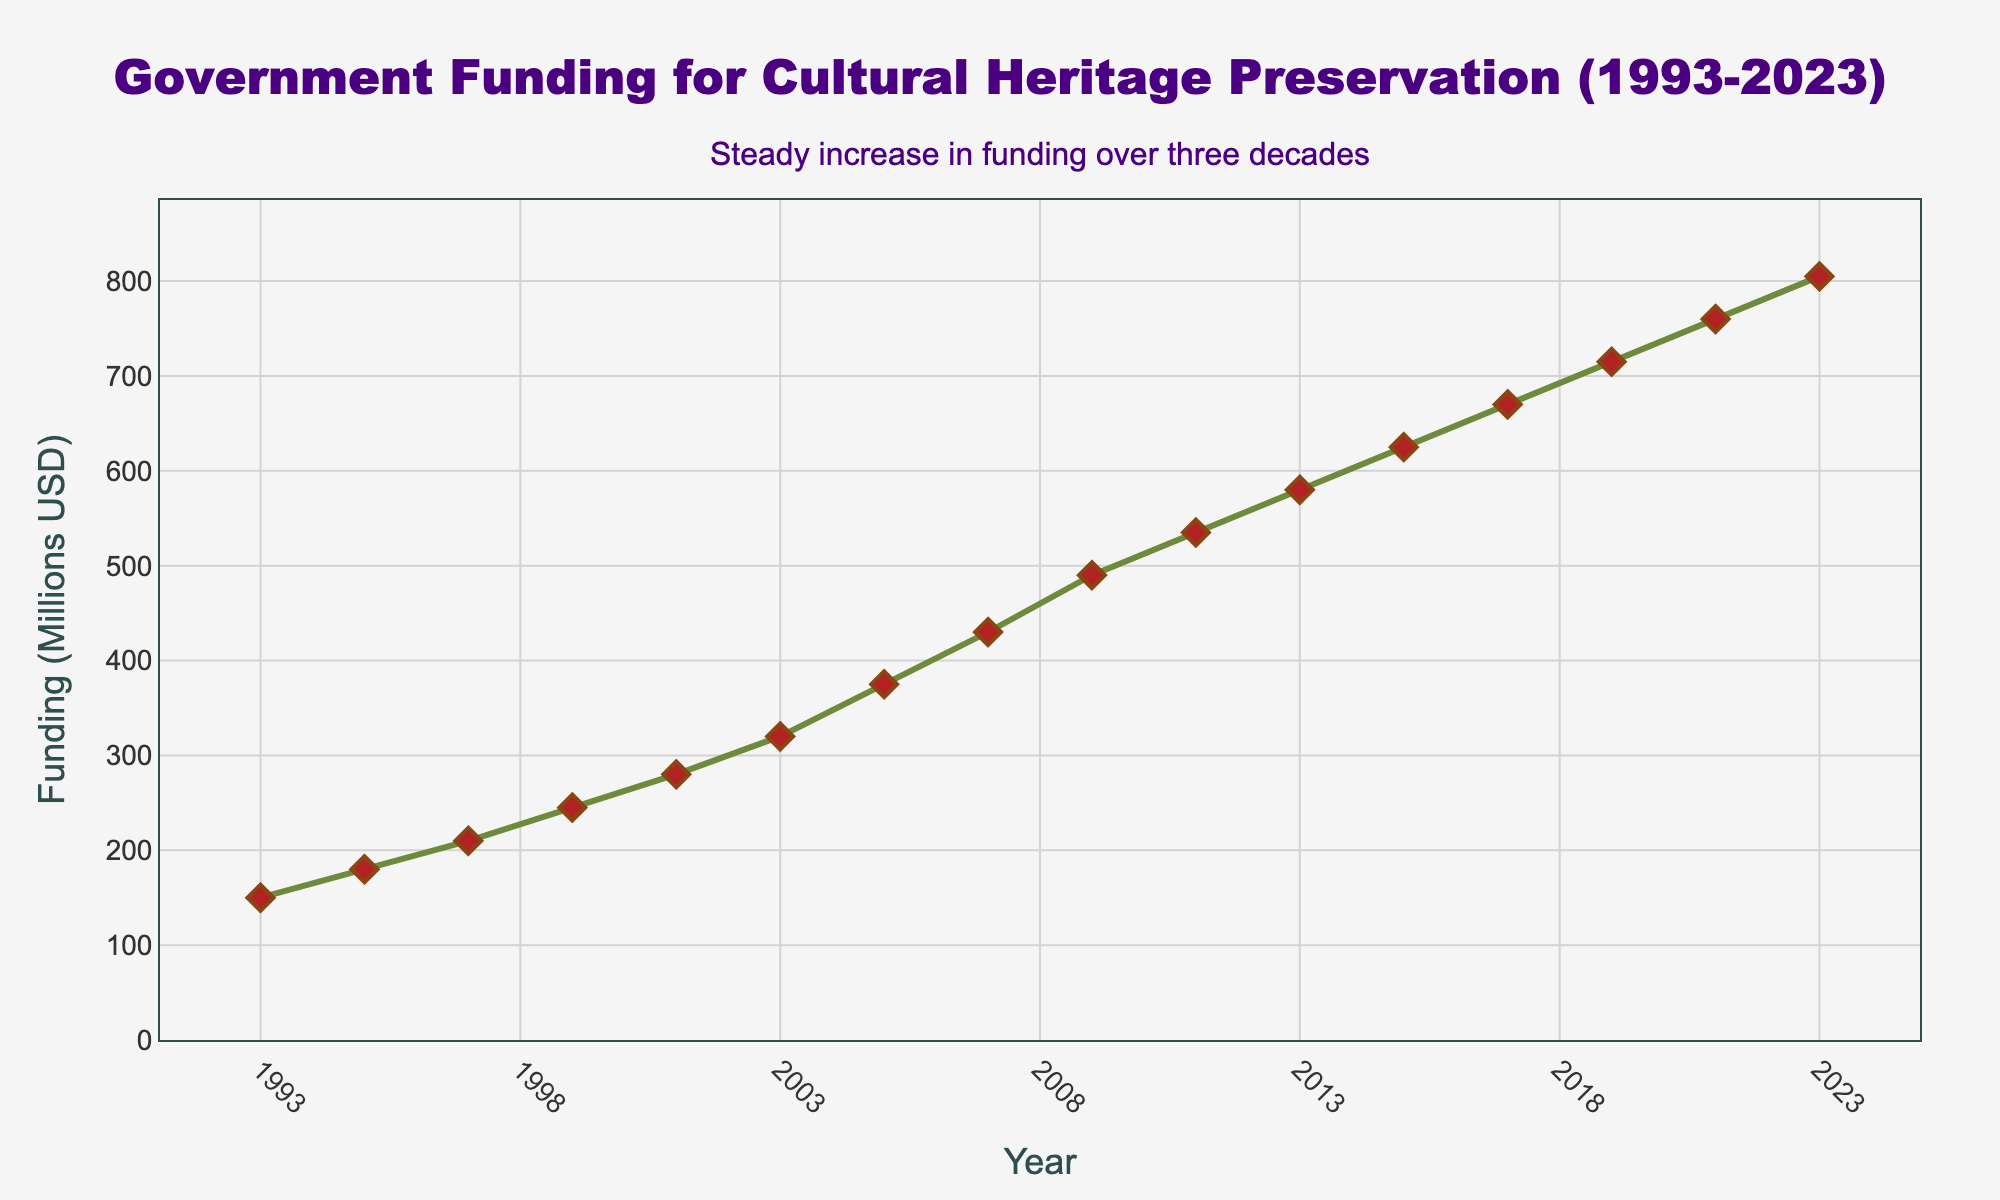What is the total funding allocated for cultural heritage preservation from 1993 to 2023? Sum up the funding values for each year from 1993 to 2023 mentioned in the dataset: 150 + 180 + 210 + 245 + 280 + 320 + 375 + 430 + 490 + 535 + 580 + 625 + 670 + 715 + 760 + 805 = 7870
Answer: 7870 Between which years did the funding experience the largest increase, and what was the amount of this increase? Calculate the differences between consecutive years' funding, and identify the largest difference. The differences are: 180-150=30, 210-180=30, 245-210=35, 280-245=35, 320-280=40, 375-320=55, 430-375=55, 490-430=60, 535-490=45, 580-535=45, 625-580=45, 670-625=45, 715-670=45, 760-715=45, 805-760=45. The largest increase is 60, which occurred between 2007 and 2009.
Answer: 2007 to 2009, 60 million USD What is the average annual funding over the 30-year period? Sum the funding values from 1993 to 2023, then divide by the number of years (7870/16). The calculation is 7870/16 = 491.875
Answer: 491.875 million USD What can you infer about the overall trend in government funding for cultural heritage preservation from 1993 to 2023? Examine the line chart and observe the trend in funding over the years. The trend shows a steady and continuous increase in funding, without any noticeable declines, indicating a positive commitment to cultural heritage preservation.
Answer: Steady increase Which year had the lowest funding allocation, and what was the amount? Look for the lowest point on the line chart, which corresponds to the year with the minimum funding. In the dataset, the lowest funding is 150 million USD in 1993.
Answer: 1993, 150 million USD By how much did the funding increase from 1993 to 2023? Subtract the funding amount in 1993 from the funding amount in 2023: 805 - 150 = 655 million USD
Answer: 655 million USD In which time span did the funding grow more rapidly: 1993-2003 or 2013-2023? Calculate the total funding increases for each period: (320-150) = 170 million for 1993-2003, and (805-580) = 225 million for 2013-2023. Comparing these increases, the growth is more rapid in the period 2013-2023.
Answer: 2013-2023 What is the median funding value during this 30-year period? Sort the funding values and identify the middle value. The sorted values are: 150, 180, 210, 245, 280, 320, 375, 430, 490, 535, 580, 625, 670, 715, 760, 805. With 16 data points, the median is the average of the 8th and 9th values: (430 + 490) / 2 = 460
Answer: 460 million USD What is the difference in funding between the years 2001 and 2003? Subtract the funding amount in 2001 from the funding amount in 2003: 320 - 280 = 40 million USD
Answer: 40 million USD 